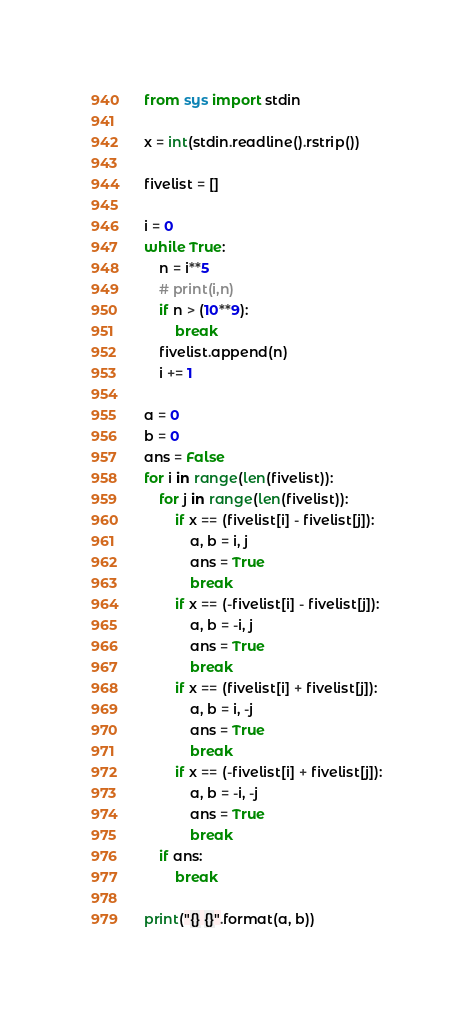<code> <loc_0><loc_0><loc_500><loc_500><_Python_>from sys import stdin

x = int(stdin.readline().rstrip())

fivelist = []

i = 0
while True:
    n = i**5
    # print(i,n)
    if n > (10**9):
        break
    fivelist.append(n)
    i += 1

a = 0
b = 0
ans = False
for i in range(len(fivelist)):
    for j in range(len(fivelist)):
        if x == (fivelist[i] - fivelist[j]):
            a, b = i, j
            ans = True
            break
        if x == (-fivelist[i] - fivelist[j]):
            a, b = -i, j
            ans = True
            break
        if x == (fivelist[i] + fivelist[j]):
            a, b = i, -j
            ans = True
            break
        if x == (-fivelist[i] + fivelist[j]):
            a, b = -i, -j
            ans = True
            break
    if ans:
        break

print("{} {}".format(a, b))
</code> 